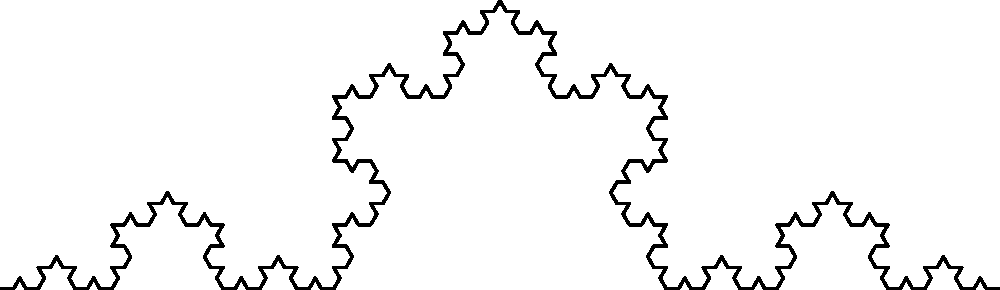The image shows a Koch snowflake curve, a famous fractal. If we start with a line segment of length 1 and continue this pattern indefinitely, what is the length of the curve after $n$ iterations, in terms of $n$? Let's approach this step-by-step:

1) In each iteration, every line segment is replaced by 4 smaller segments.

2) Each of these new segments has a length of 1/3 of the original segment.

3) Let's denote the length after $n$ iterations as $L_n$. We start with $L_0 = 1$.

4) In the first iteration:
   $L_1 = 4 * (1/3) * L_0 = 4/3 * L_0 = 4/3$

5) In the second iteration:
   $L_2 = 4/3 * L_1 = (4/3)^2$

6) We can see a pattern forming. After $n$ iterations:
   $L_n = (4/3)^n$

This forms a geometric sequence with first term $a = 1$ and common ratio $r = 4/3$.

7) The formula for the $n$-th term of a geometric sequence is $ar^{n-1}$, but since we start at $n=0$, our formula is $ar^n$.

Therefore, the length of the Koch snowflake curve after $n$ iterations is $(4/3)^n$.
Answer: $$(4/3)^n$$ 